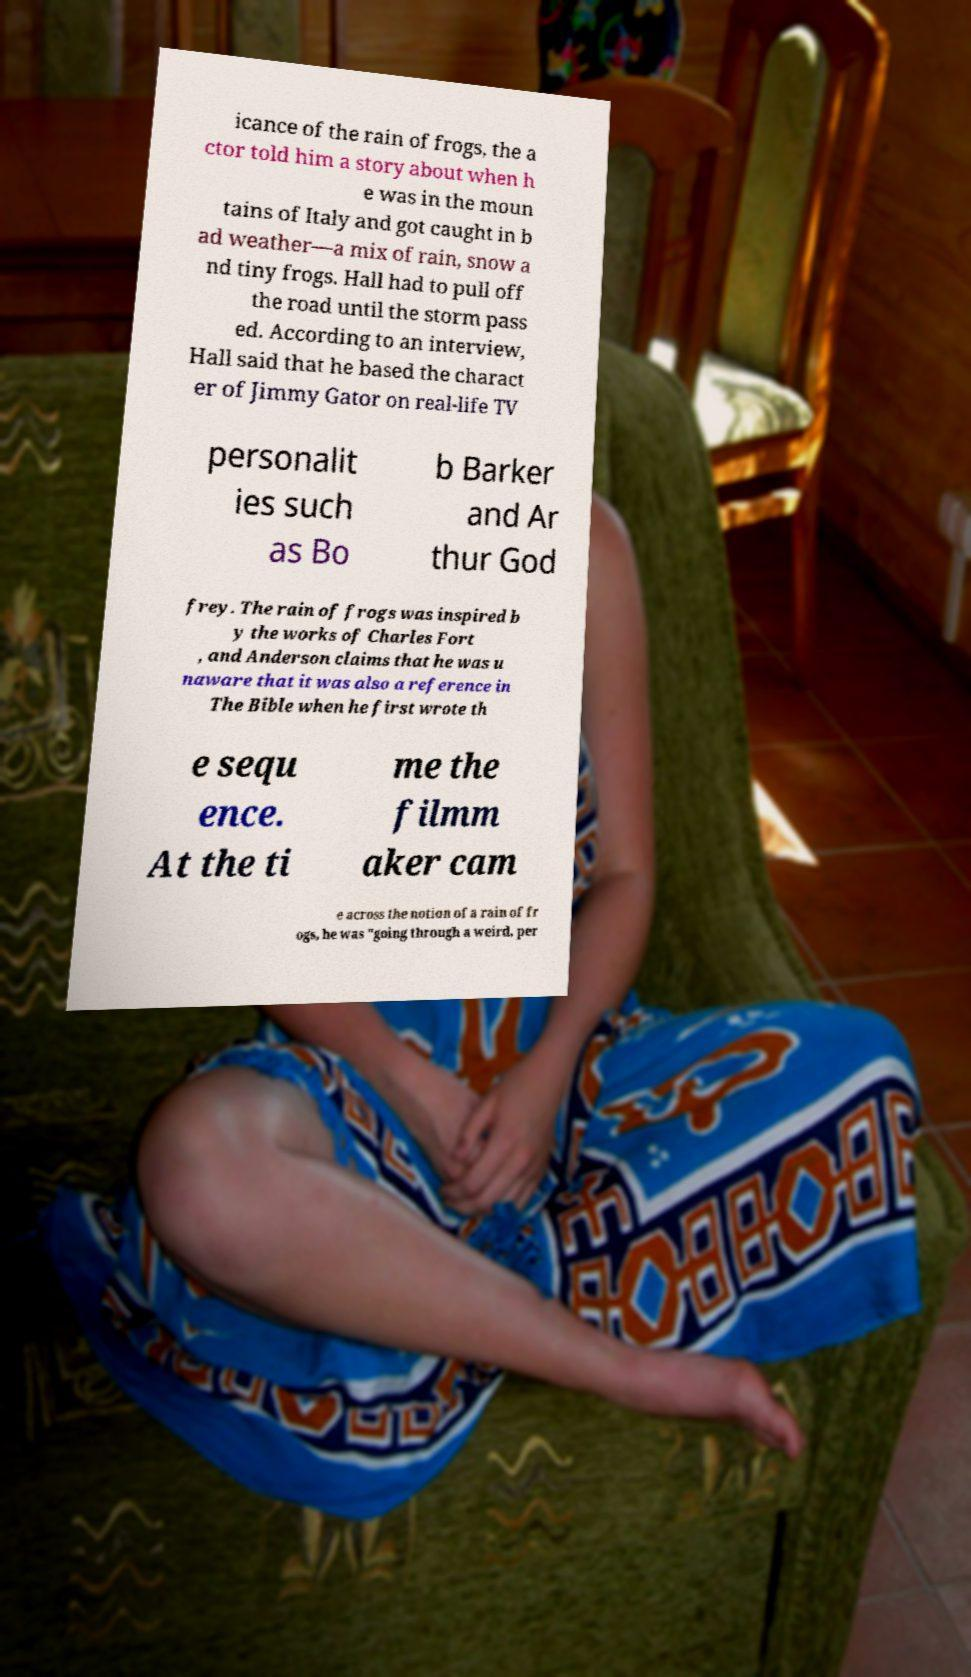What messages or text are displayed in this image? I need them in a readable, typed format. icance of the rain of frogs, the a ctor told him a story about when h e was in the moun tains of Italy and got caught in b ad weather—a mix of rain, snow a nd tiny frogs. Hall had to pull off the road until the storm pass ed. According to an interview, Hall said that he based the charact er of Jimmy Gator on real-life TV personalit ies such as Bo b Barker and Ar thur God frey. The rain of frogs was inspired b y the works of Charles Fort , and Anderson claims that he was u naware that it was also a reference in The Bible when he first wrote th e sequ ence. At the ti me the filmm aker cam e across the notion of a rain of fr ogs, he was "going through a weird, per 